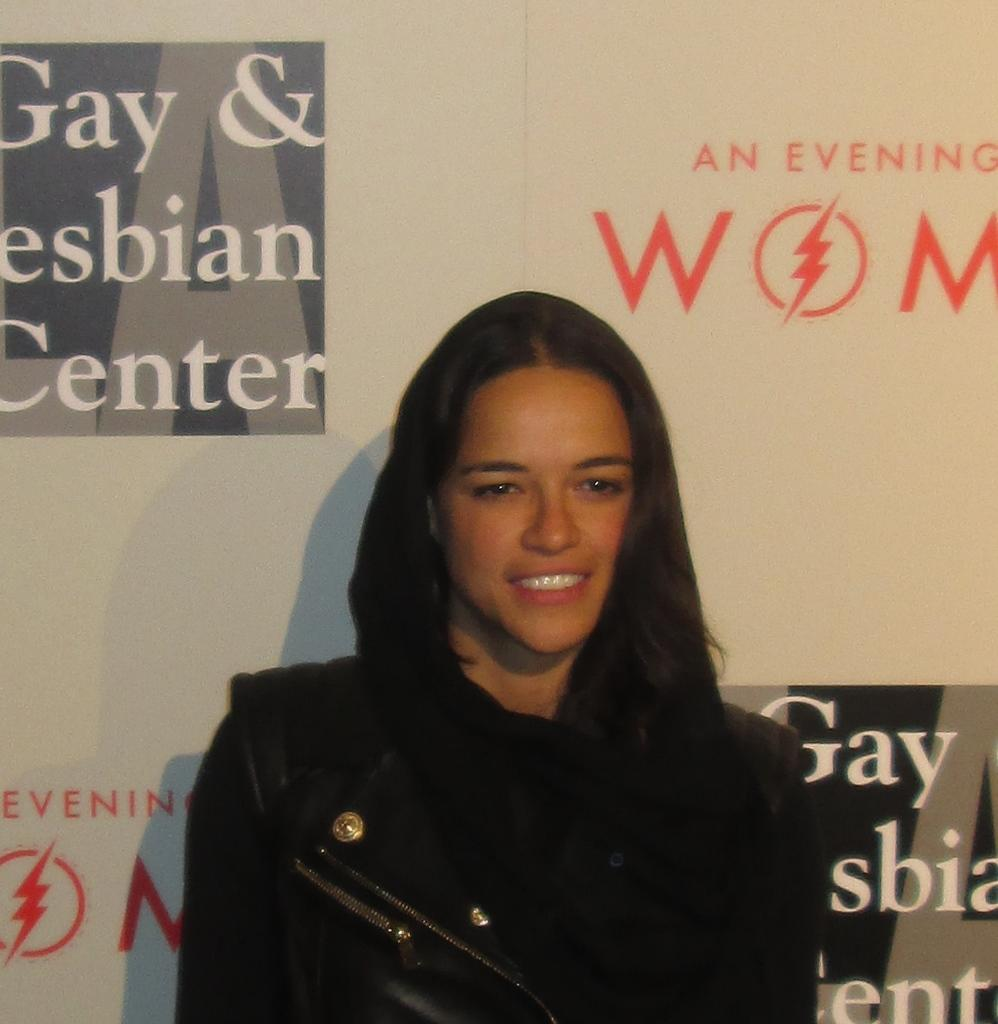Who is in the picture? There is a woman in the picture. What is the woman doing in the picture? The woman is standing. What is the woman wearing in the picture? The woman is wearing a black dress. What is the woman's facial expression in the picture? The woman is smiling. What can be seen in the background of the picture? There is a banner in the background of the picture. What is written on the banner? There is writing on the banner. What hobbies does the woman enjoy in the park? There is no information about the woman's hobbies or the park in the image. 